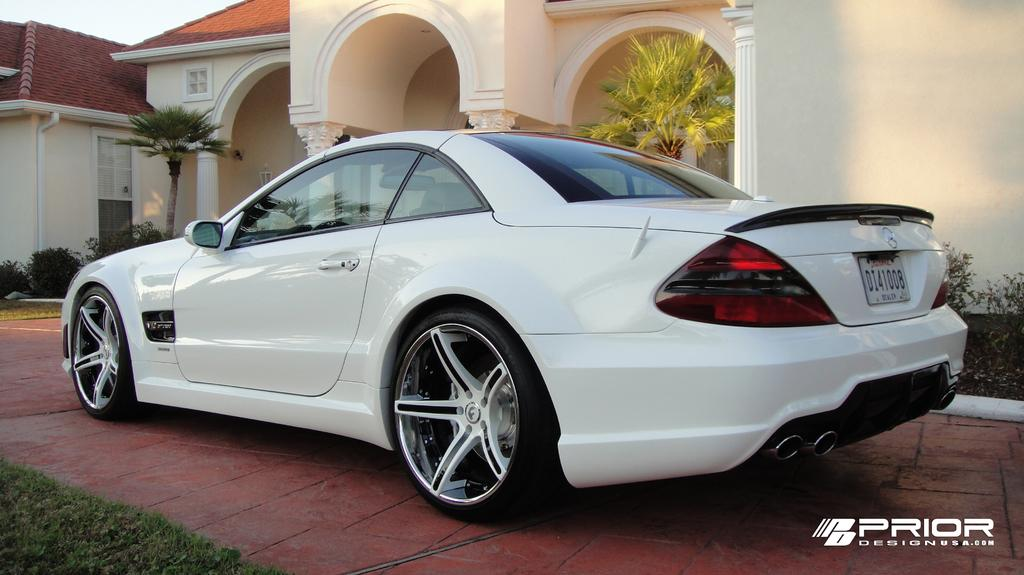What type of vehicle is parked near the wall in the image? There is a white car parked near the wall in the image. What kind of building can be seen in the image? There is a big house in the image. Can you describe the lighting in the image? There is a light in the image. What is attached to the wall in the image? There is a pipe attached to the wall. What type of vegetation is present in the image? There are trees, bushes, and plants in the image. What is the ground covered with in the image? There is green grass on the ground. What type of skin condition can be seen on the trees in the image? There is no mention of any skin condition on the trees in the image. What type of fruit is hanging from the pipe in the image? There is no fruit hanging from the pipe in the image. 